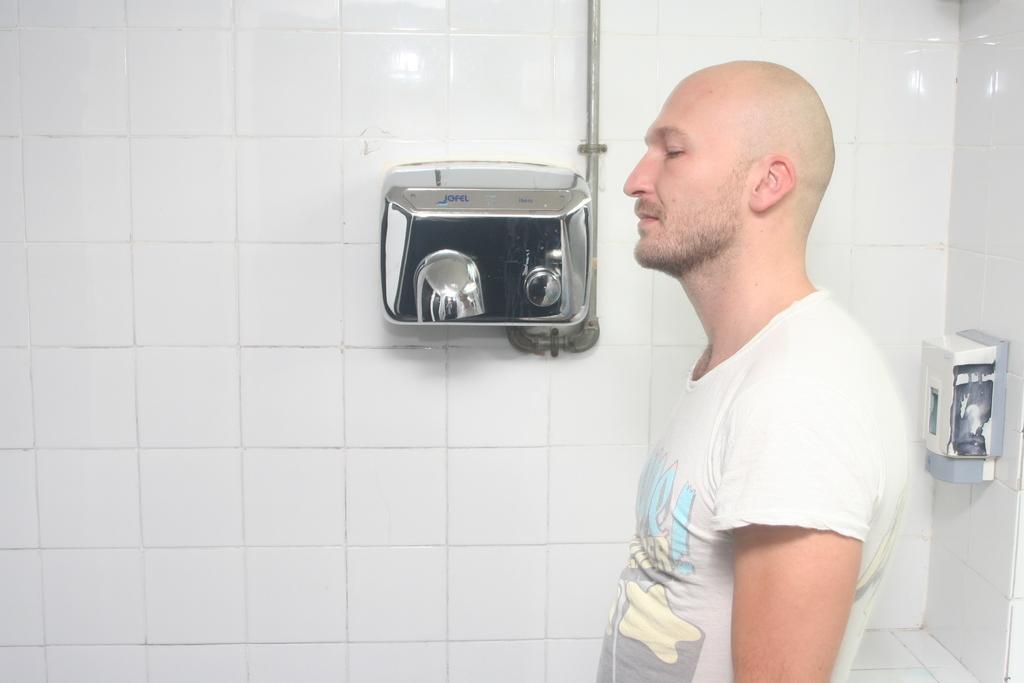Could you give a brief overview of what you see in this image? In this image we can see a man. On the right side there is a wall with a soap dispenser. In the back there is a wall with an object. 